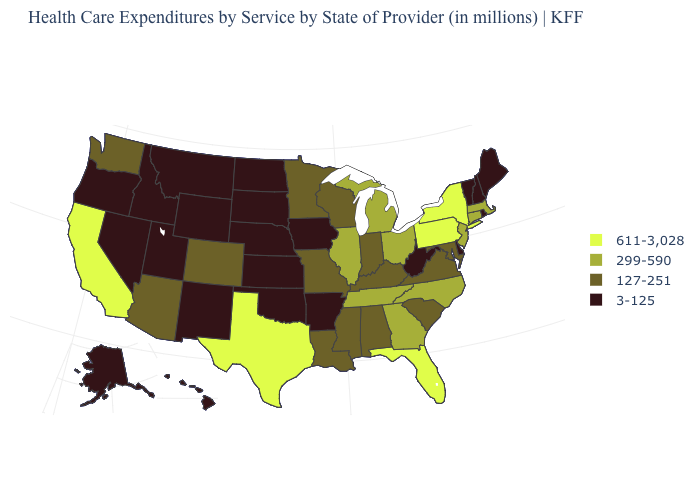Name the states that have a value in the range 3-125?
Quick response, please. Alaska, Arkansas, Delaware, Hawaii, Idaho, Iowa, Kansas, Maine, Montana, Nebraska, Nevada, New Hampshire, New Mexico, North Dakota, Oklahoma, Oregon, Rhode Island, South Dakota, Utah, Vermont, West Virginia, Wyoming. Is the legend a continuous bar?
Quick response, please. No. What is the value of Vermont?
Give a very brief answer. 3-125. Does Massachusetts have the lowest value in the Northeast?
Be succinct. No. Among the states that border Missouri , which have the lowest value?
Be succinct. Arkansas, Iowa, Kansas, Nebraska, Oklahoma. What is the value of Georgia?
Write a very short answer. 299-590. Name the states that have a value in the range 3-125?
Give a very brief answer. Alaska, Arkansas, Delaware, Hawaii, Idaho, Iowa, Kansas, Maine, Montana, Nebraska, Nevada, New Hampshire, New Mexico, North Dakota, Oklahoma, Oregon, Rhode Island, South Dakota, Utah, Vermont, West Virginia, Wyoming. Does Ohio have the highest value in the USA?
Answer briefly. No. Name the states that have a value in the range 127-251?
Give a very brief answer. Alabama, Arizona, Colorado, Indiana, Kentucky, Louisiana, Maryland, Minnesota, Mississippi, Missouri, South Carolina, Virginia, Washington, Wisconsin. Name the states that have a value in the range 3-125?
Quick response, please. Alaska, Arkansas, Delaware, Hawaii, Idaho, Iowa, Kansas, Maine, Montana, Nebraska, Nevada, New Hampshire, New Mexico, North Dakota, Oklahoma, Oregon, Rhode Island, South Dakota, Utah, Vermont, West Virginia, Wyoming. Name the states that have a value in the range 127-251?
Answer briefly. Alabama, Arizona, Colorado, Indiana, Kentucky, Louisiana, Maryland, Minnesota, Mississippi, Missouri, South Carolina, Virginia, Washington, Wisconsin. Name the states that have a value in the range 611-3,028?
Quick response, please. California, Florida, New York, Pennsylvania, Texas. What is the value of South Dakota?
Give a very brief answer. 3-125. Among the states that border Minnesota , which have the lowest value?
Short answer required. Iowa, North Dakota, South Dakota. Name the states that have a value in the range 611-3,028?
Quick response, please. California, Florida, New York, Pennsylvania, Texas. 